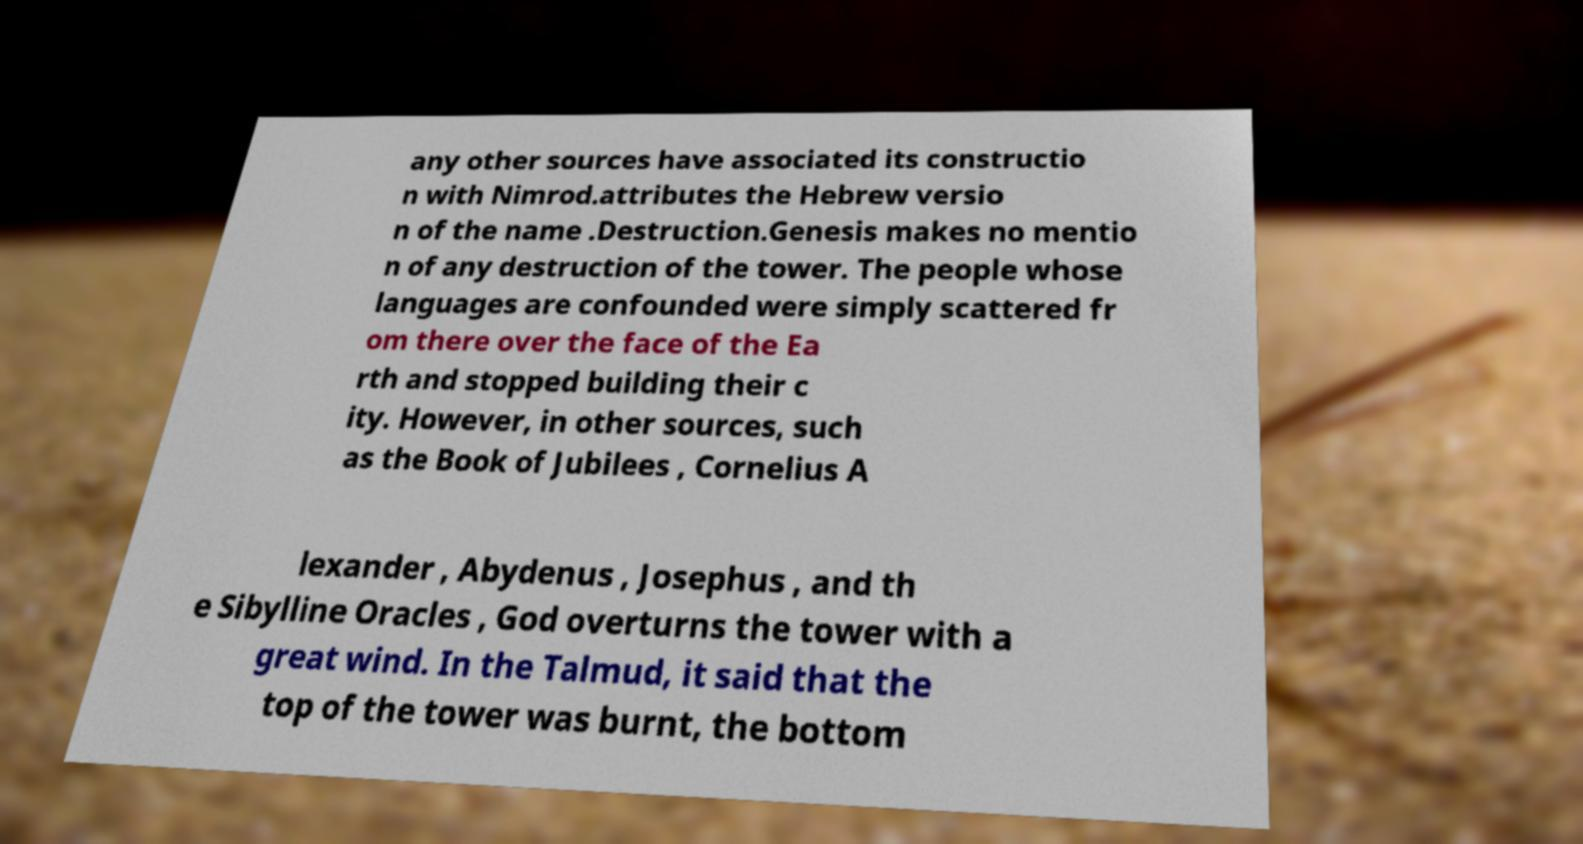Can you read and provide the text displayed in the image?This photo seems to have some interesting text. Can you extract and type it out for me? any other sources have associated its constructio n with Nimrod.attributes the Hebrew versio n of the name .Destruction.Genesis makes no mentio n of any destruction of the tower. The people whose languages are confounded were simply scattered fr om there over the face of the Ea rth and stopped building their c ity. However, in other sources, such as the Book of Jubilees , Cornelius A lexander , Abydenus , Josephus , and th e Sibylline Oracles , God overturns the tower with a great wind. In the Talmud, it said that the top of the tower was burnt, the bottom 